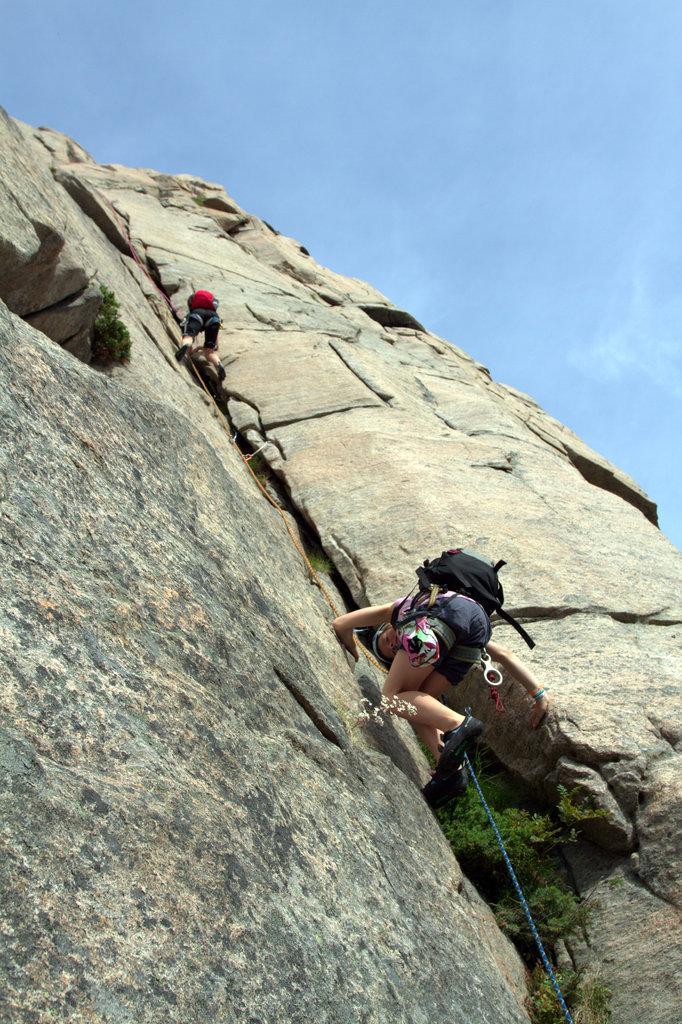Please provide a concise description of this image. In the center of the image there are two people climbing a mountain. There is a rope. At the top of the image there is sky. 